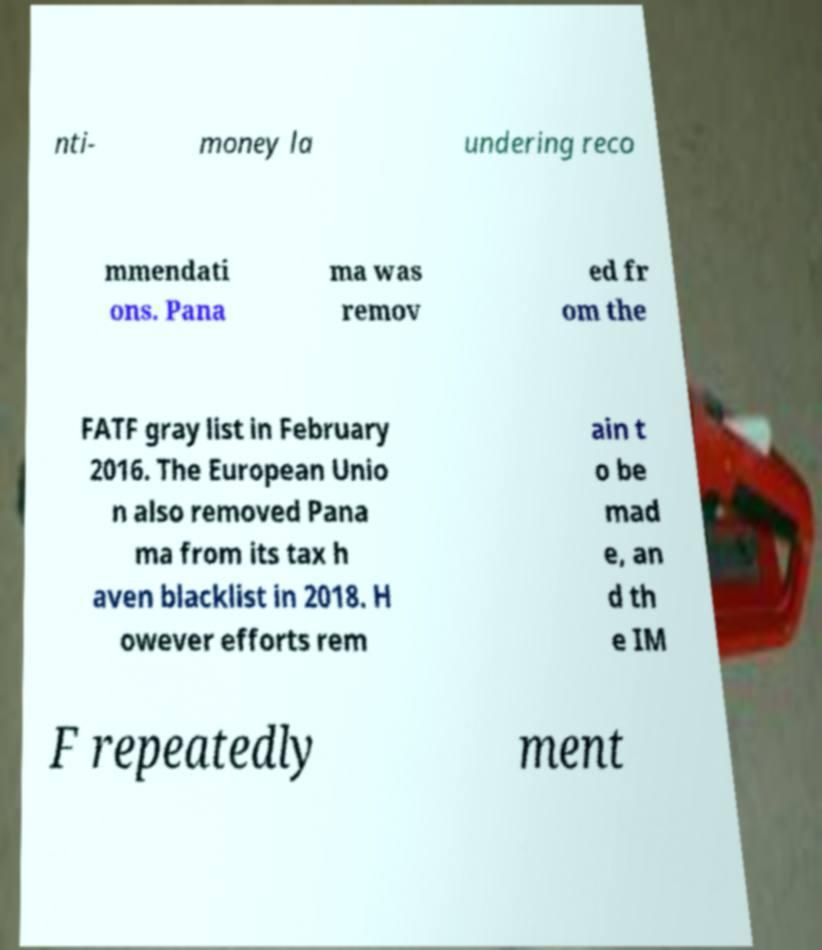What messages or text are displayed in this image? I need them in a readable, typed format. nti- money la undering reco mmendati ons. Pana ma was remov ed fr om the FATF gray list in February 2016. The European Unio n also removed Pana ma from its tax h aven blacklist in 2018. H owever efforts rem ain t o be mad e, an d th e IM F repeatedly ment 